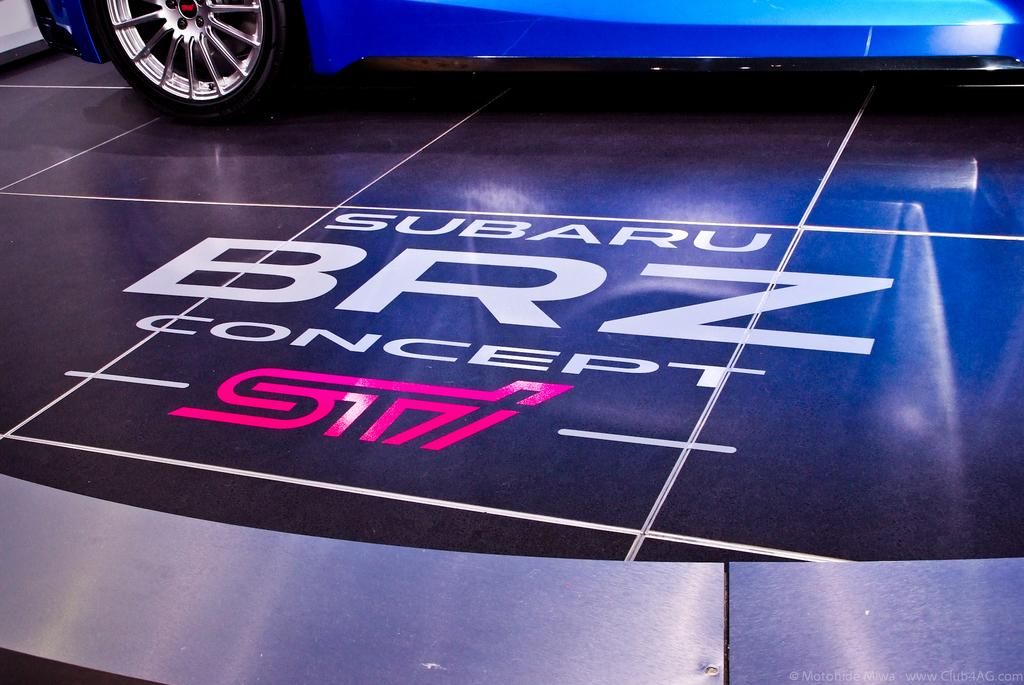What type of vehicle is in the image? There is a blue color car in the image. What is the surface beneath the car? The car is on a black surface. Is there any text or writing on the car? Yes, there is writing on the car. Can you see a hen attempting to teach the car in the image? There is no hen or any teaching activity present in the image. 